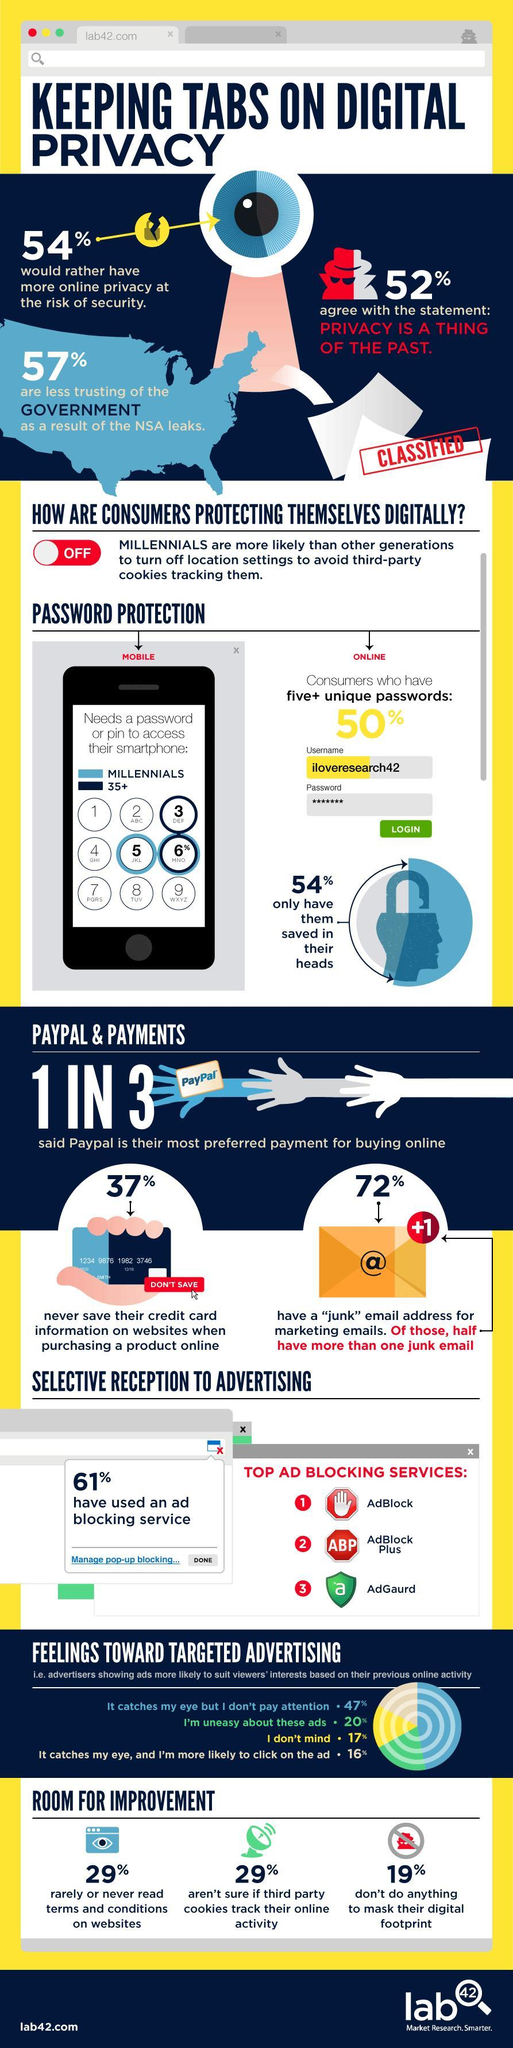What percentage of millennials still use a password to access their smart phone ?
Answer the question with a short phrase. 6% What percentage of people do not care about the hiding their online activities, 19%, 29%, or 16%?? 19% What percentage would not want to have online privacy ? 46% What percentage of people still agree that privacy is crucial? 48% What percentage of people never read the terms and conditions or aren't sure if their online activity is tracked? 29% What is the total percentage of people who do no mind and who do not take notice of targeted ads ? 64% What percentage do not use any ad blocking service? 39% What percentage of people still trust the government ? 47% 